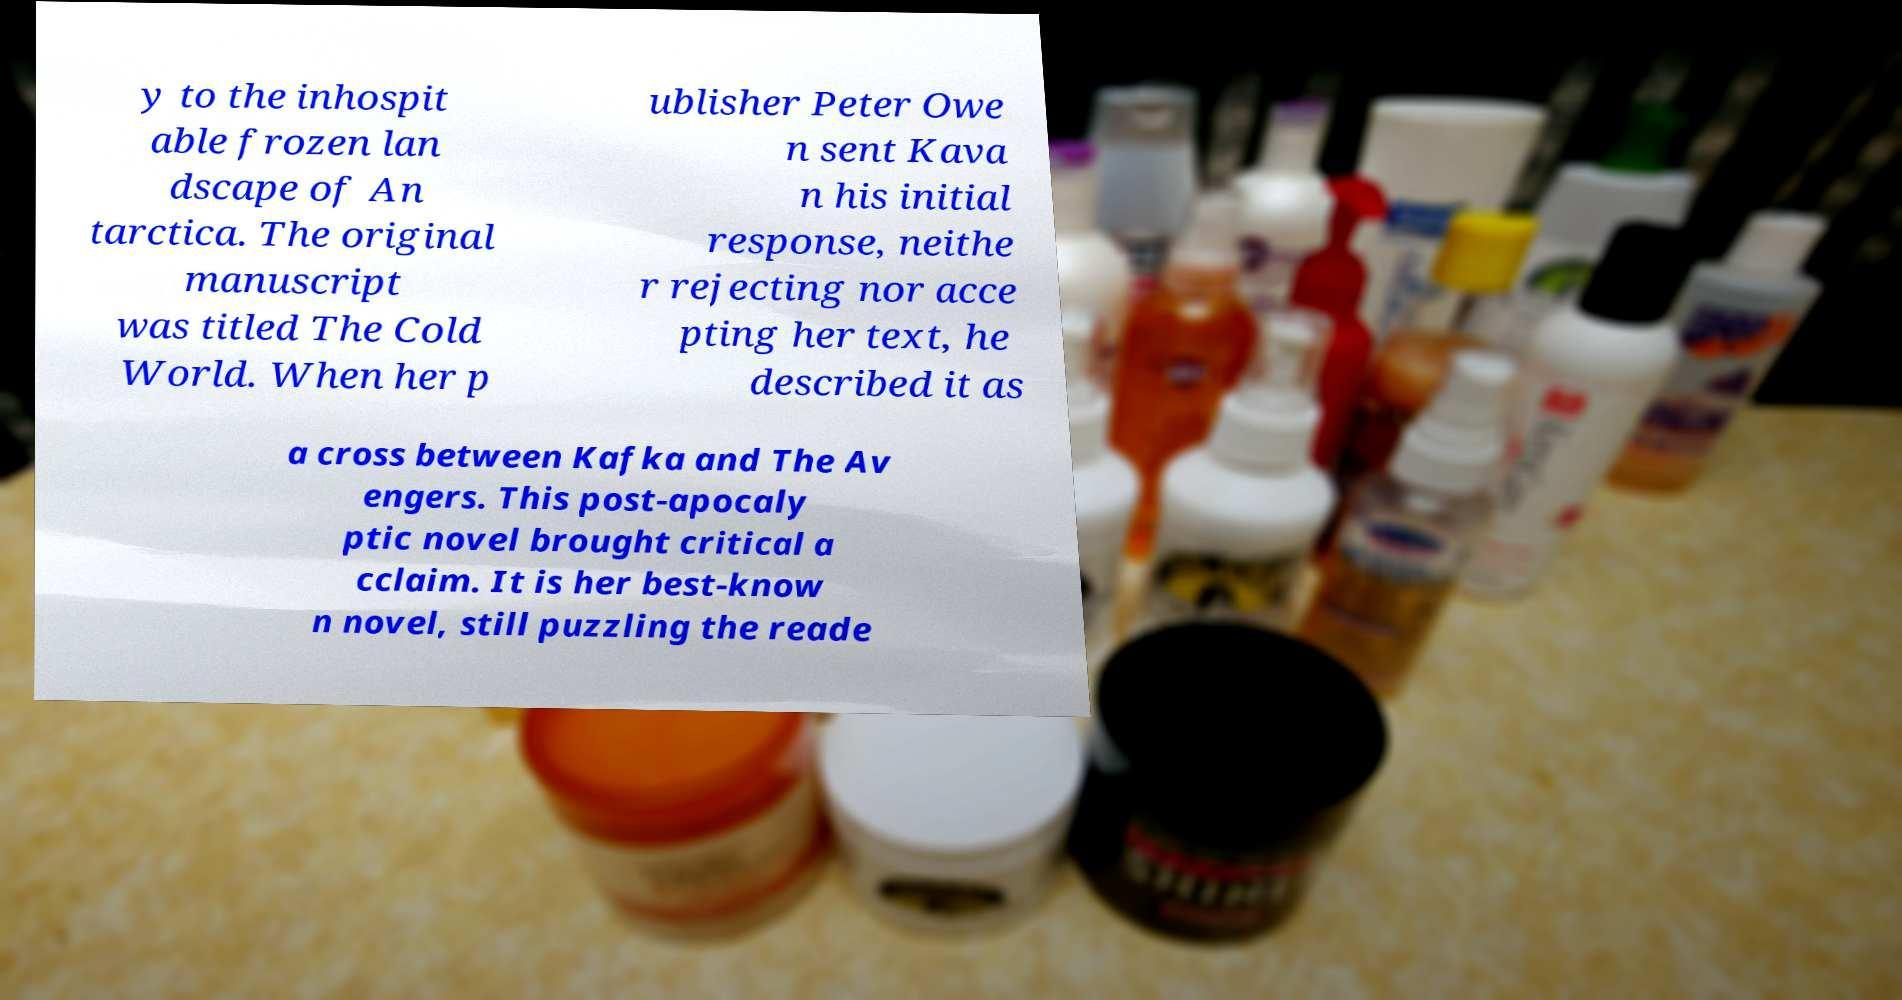What messages or text are displayed in this image? I need them in a readable, typed format. y to the inhospit able frozen lan dscape of An tarctica. The original manuscript was titled The Cold World. When her p ublisher Peter Owe n sent Kava n his initial response, neithe r rejecting nor acce pting her text, he described it as a cross between Kafka and The Av engers. This post-apocaly ptic novel brought critical a cclaim. It is her best-know n novel, still puzzling the reade 